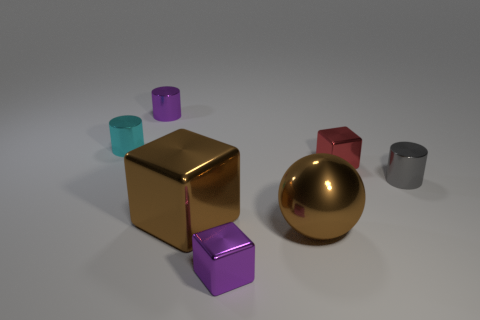What color is the metal object that is behind the brown cube and in front of the tiny red block?
Make the answer very short. Gray. The tiny object that is in front of the gray shiny object has what shape?
Your response must be concise. Cube. There is a purple object that is in front of the tiny metallic cylinder that is to the left of the purple object that is to the left of the large brown cube; how big is it?
Offer a very short reply. Small. How many small things are in front of the tiny metallic object that is right of the tiny red metal cube?
Offer a very short reply. 1. What is the size of the metallic cylinder that is both right of the tiny cyan thing and left of the tiny red metallic thing?
Keep it short and to the point. Small. How many metal objects are large red cubes or cyan cylinders?
Ensure brevity in your answer.  1. What material is the tiny red cube?
Offer a very short reply. Metal. What material is the tiny block that is to the left of the shiny block behind the tiny metallic cylinder that is to the right of the brown shiny sphere made of?
Your response must be concise. Metal. What is the shape of the gray object that is the same size as the cyan shiny cylinder?
Provide a succinct answer. Cylinder. How many things are either tiny metallic cylinders or tiny gray things that are in front of the cyan object?
Offer a terse response. 3. 